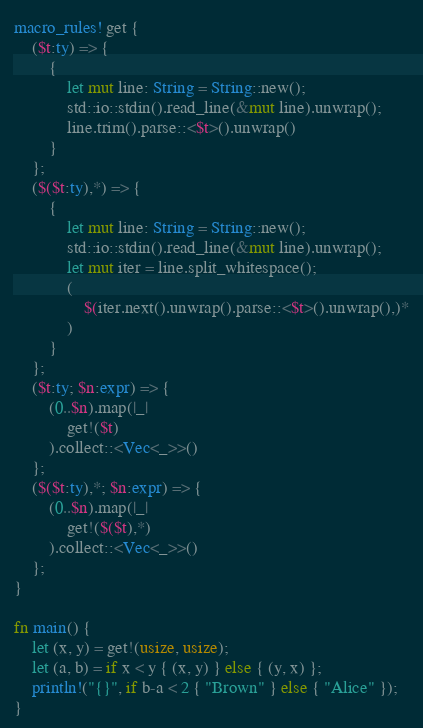Convert code to text. <code><loc_0><loc_0><loc_500><loc_500><_Rust_>macro_rules! get {
    ($t:ty) => {
        {
            let mut line: String = String::new();
            std::io::stdin().read_line(&mut line).unwrap();
            line.trim().parse::<$t>().unwrap()
        }
    };
    ($($t:ty),*) => {
        {
            let mut line: String = String::new();
            std::io::stdin().read_line(&mut line).unwrap();
            let mut iter = line.split_whitespace();
            (
                $(iter.next().unwrap().parse::<$t>().unwrap(),)*
            )
        }
    };
    ($t:ty; $n:expr) => {
        (0..$n).map(|_|
            get!($t)
        ).collect::<Vec<_>>()
    };
    ($($t:ty),*; $n:expr) => {
        (0..$n).map(|_|
            get!($($t),*)
        ).collect::<Vec<_>>()
    };
}

fn main() {
    let (x, y) = get!(usize, usize);
    let (a, b) = if x < y { (x, y) } else { (y, x) };
    println!("{}", if b-a < 2 { "Brown" } else { "Alice" });
}</code> 